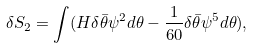<formula> <loc_0><loc_0><loc_500><loc_500>\delta S _ { 2 } = \int ( H \delta \bar { \theta } \psi ^ { 2 } d \theta - \frac { 1 } { 6 0 } \delta \bar { \theta } \psi ^ { 5 } d \theta ) ,</formula> 